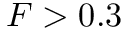Convert formula to latex. <formula><loc_0><loc_0><loc_500><loc_500>F > 0 . 3</formula> 